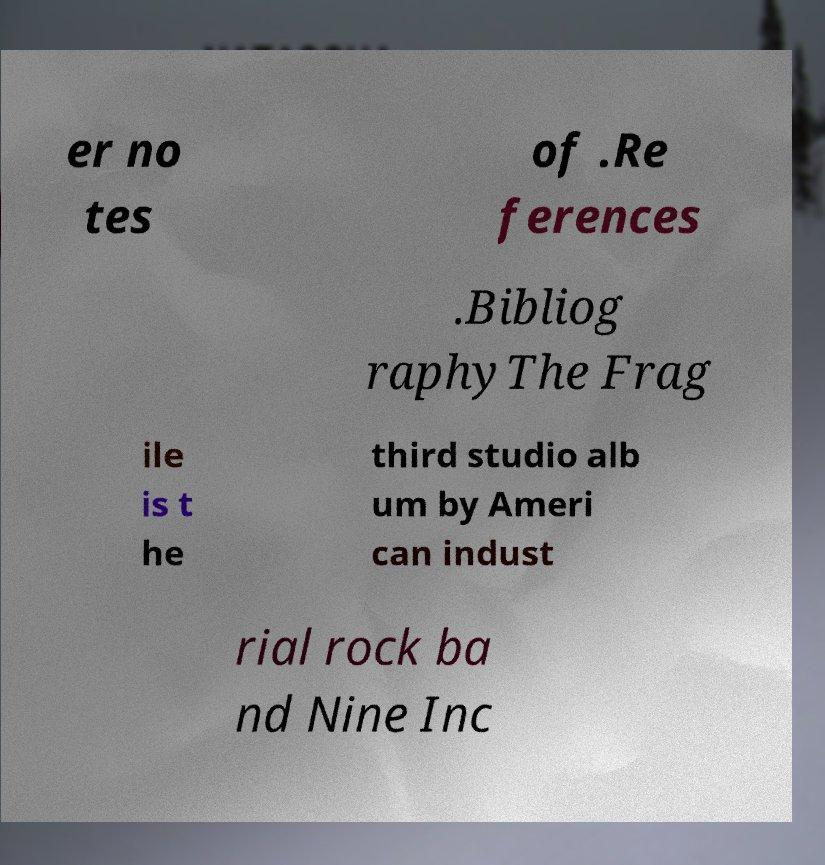I need the written content from this picture converted into text. Can you do that? er no tes of .Re ferences .Bibliog raphyThe Frag ile is t he third studio alb um by Ameri can indust rial rock ba nd Nine Inc 